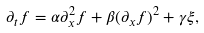Convert formula to latex. <formula><loc_0><loc_0><loc_500><loc_500>\partial _ { t } f = \alpha \partial _ { x } ^ { 2 } f + \beta ( \partial _ { x } f ) ^ { 2 } + \gamma \xi ,</formula> 